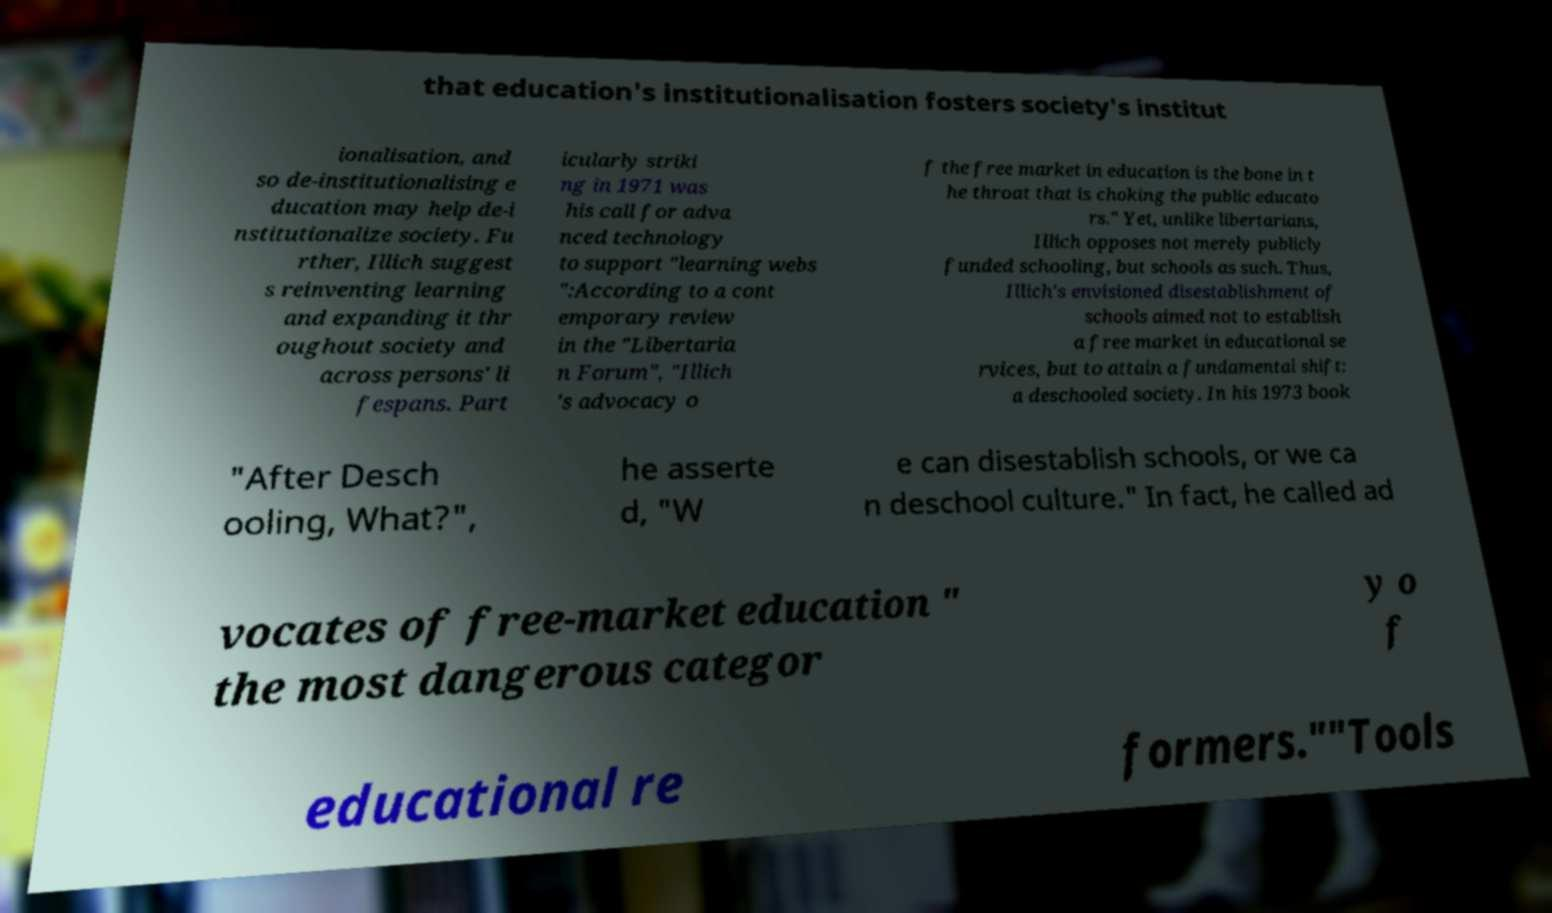Can you accurately transcribe the text from the provided image for me? that education's institutionalisation fosters society's institut ionalisation, and so de-institutionalising e ducation may help de-i nstitutionalize society. Fu rther, Illich suggest s reinventing learning and expanding it thr oughout society and across persons' li fespans. Part icularly striki ng in 1971 was his call for adva nced technology to support "learning webs ":According to a cont emporary review in the "Libertaria n Forum", "Illich 's advocacy o f the free market in education is the bone in t he throat that is choking the public educato rs." Yet, unlike libertarians, Illich opposes not merely publicly funded schooling, but schools as such. Thus, Illich's envisioned disestablishment of schools aimed not to establish a free market in educational se rvices, but to attain a fundamental shift: a deschooled society. In his 1973 book "After Desch ooling, What?", he asserte d, "W e can disestablish schools, or we ca n deschool culture." In fact, he called ad vocates of free-market education " the most dangerous categor y o f educational re formers.""Tools 